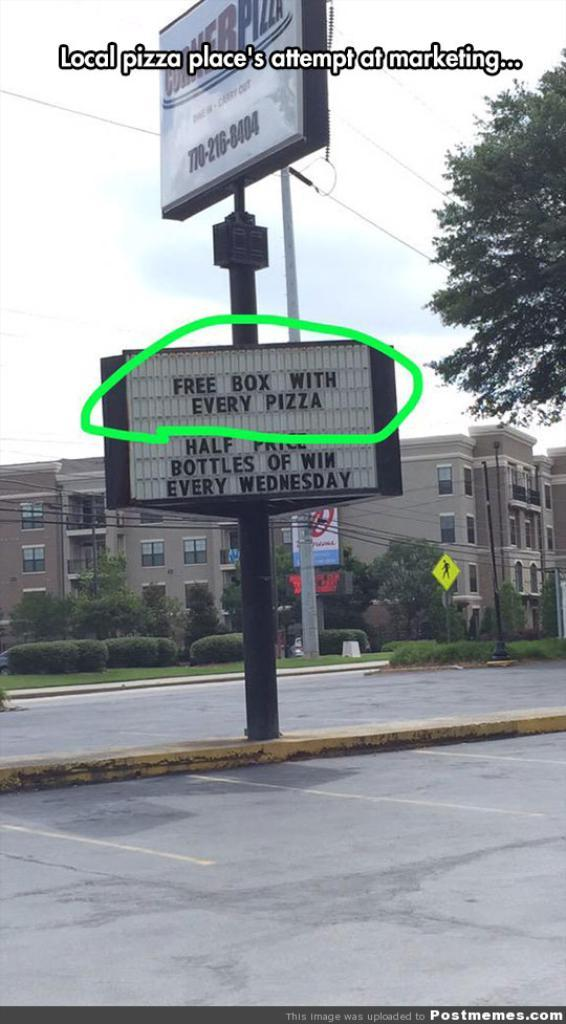<image>
Describe the image concisely. a sign claiming to give a free box with pizza 